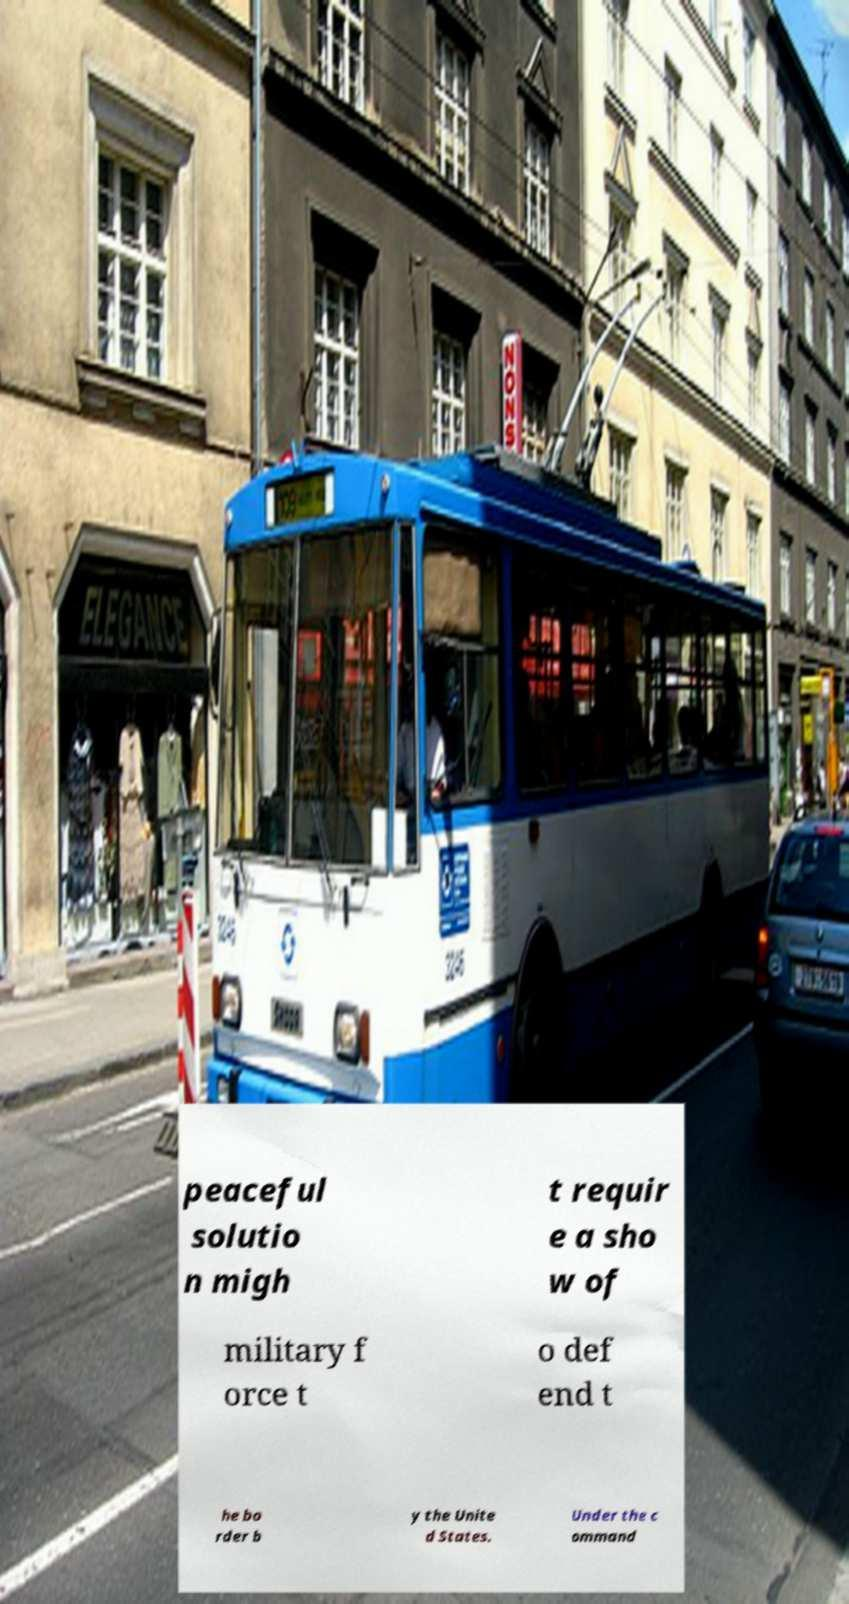Can you read and provide the text displayed in the image?This photo seems to have some interesting text. Can you extract and type it out for me? peaceful solutio n migh t requir e a sho w of military f orce t o def end t he bo rder b y the Unite d States. Under the c ommand 